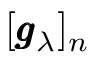<formula> <loc_0><loc_0><loc_500><loc_500>[ \pm b { g } _ { \lambda } ] _ { n }</formula> 